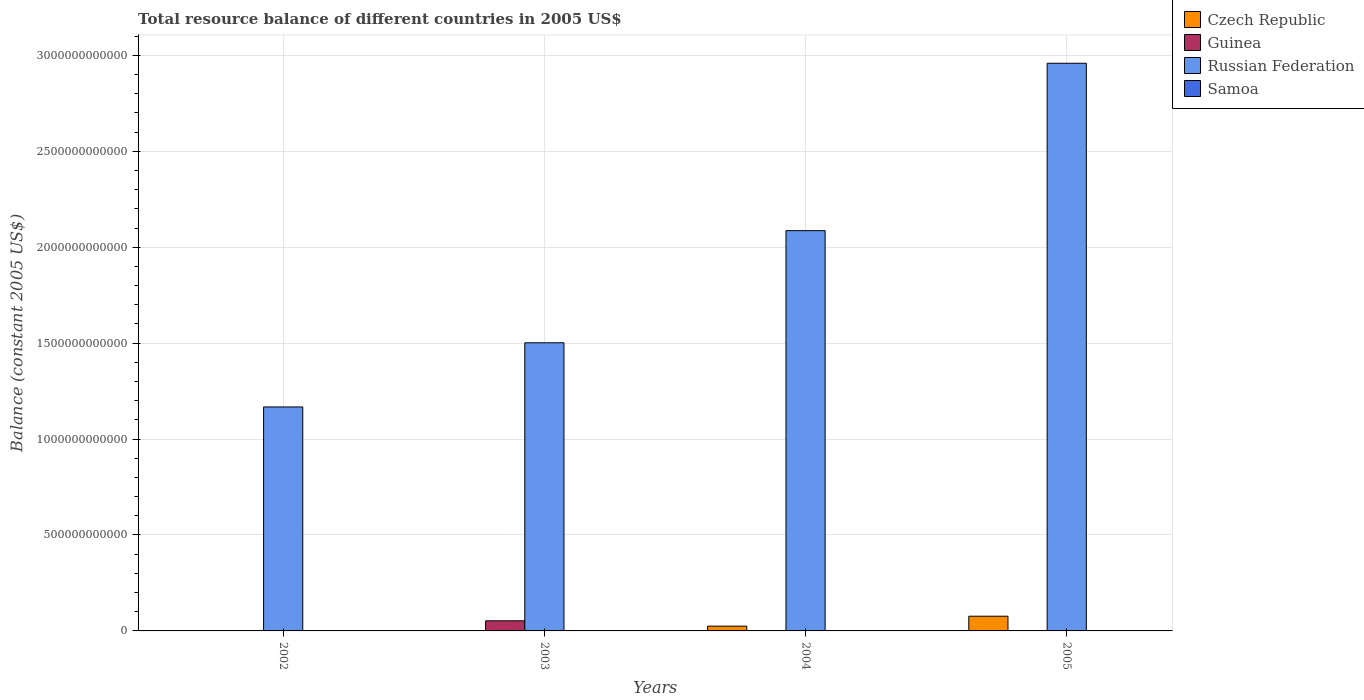How many different coloured bars are there?
Provide a short and direct response. 3. Are the number of bars per tick equal to the number of legend labels?
Offer a terse response. No. Are the number of bars on each tick of the X-axis equal?
Ensure brevity in your answer.  No. How many bars are there on the 3rd tick from the left?
Offer a terse response. 2. How many bars are there on the 4th tick from the right?
Give a very brief answer. 1. In how many cases, is the number of bars for a given year not equal to the number of legend labels?
Make the answer very short. 4. What is the total resource balance in Russian Federation in 2002?
Your answer should be very brief. 1.17e+12. Across all years, what is the maximum total resource balance in Czech Republic?
Provide a succinct answer. 7.67e+1. Across all years, what is the minimum total resource balance in Russian Federation?
Ensure brevity in your answer.  1.17e+12. What is the total total resource balance in Russian Federation in the graph?
Make the answer very short. 7.72e+12. What is the difference between the total resource balance in Russian Federation in 2002 and that in 2005?
Make the answer very short. -1.79e+12. What is the difference between the total resource balance in Czech Republic in 2005 and the total resource balance in Samoa in 2004?
Offer a terse response. 7.67e+1. What is the average total resource balance in Czech Republic per year?
Offer a terse response. 2.54e+1. In the year 2003, what is the difference between the total resource balance in Guinea and total resource balance in Russian Federation?
Keep it short and to the point. -1.45e+12. What is the ratio of the total resource balance in Russian Federation in 2002 to that in 2003?
Give a very brief answer. 0.78. What is the difference between the highest and the second highest total resource balance in Russian Federation?
Your answer should be very brief. 8.72e+11. What is the difference between the highest and the lowest total resource balance in Czech Republic?
Provide a succinct answer. 7.67e+1. Is the sum of the total resource balance in Russian Federation in 2002 and 2004 greater than the maximum total resource balance in Guinea across all years?
Your answer should be very brief. Yes. Is it the case that in every year, the sum of the total resource balance in Russian Federation and total resource balance in Czech Republic is greater than the total resource balance in Samoa?
Make the answer very short. Yes. How many bars are there?
Give a very brief answer. 7. How many years are there in the graph?
Offer a terse response. 4. What is the difference between two consecutive major ticks on the Y-axis?
Provide a short and direct response. 5.00e+11. Does the graph contain any zero values?
Ensure brevity in your answer.  Yes. Where does the legend appear in the graph?
Ensure brevity in your answer.  Top right. How many legend labels are there?
Provide a short and direct response. 4. How are the legend labels stacked?
Your response must be concise. Vertical. What is the title of the graph?
Your answer should be very brief. Total resource balance of different countries in 2005 US$. What is the label or title of the X-axis?
Offer a very short reply. Years. What is the label or title of the Y-axis?
Give a very brief answer. Balance (constant 2005 US$). What is the Balance (constant 2005 US$) in Czech Republic in 2002?
Offer a terse response. 0. What is the Balance (constant 2005 US$) of Russian Federation in 2002?
Provide a succinct answer. 1.17e+12. What is the Balance (constant 2005 US$) of Samoa in 2002?
Make the answer very short. 0. What is the Balance (constant 2005 US$) in Guinea in 2003?
Give a very brief answer. 5.28e+1. What is the Balance (constant 2005 US$) of Russian Federation in 2003?
Offer a very short reply. 1.50e+12. What is the Balance (constant 2005 US$) of Samoa in 2003?
Provide a succinct answer. 0. What is the Balance (constant 2005 US$) of Czech Republic in 2004?
Offer a terse response. 2.49e+1. What is the Balance (constant 2005 US$) in Russian Federation in 2004?
Make the answer very short. 2.09e+12. What is the Balance (constant 2005 US$) in Samoa in 2004?
Give a very brief answer. 0. What is the Balance (constant 2005 US$) of Czech Republic in 2005?
Your response must be concise. 7.67e+1. What is the Balance (constant 2005 US$) in Guinea in 2005?
Give a very brief answer. 0. What is the Balance (constant 2005 US$) in Russian Federation in 2005?
Offer a terse response. 2.96e+12. What is the Balance (constant 2005 US$) in Samoa in 2005?
Your answer should be compact. 0. Across all years, what is the maximum Balance (constant 2005 US$) of Czech Republic?
Your answer should be very brief. 7.67e+1. Across all years, what is the maximum Balance (constant 2005 US$) of Guinea?
Make the answer very short. 5.28e+1. Across all years, what is the maximum Balance (constant 2005 US$) of Russian Federation?
Offer a terse response. 2.96e+12. Across all years, what is the minimum Balance (constant 2005 US$) in Czech Republic?
Offer a terse response. 0. Across all years, what is the minimum Balance (constant 2005 US$) of Russian Federation?
Your response must be concise. 1.17e+12. What is the total Balance (constant 2005 US$) in Czech Republic in the graph?
Provide a succinct answer. 1.02e+11. What is the total Balance (constant 2005 US$) of Guinea in the graph?
Your answer should be very brief. 5.28e+1. What is the total Balance (constant 2005 US$) in Russian Federation in the graph?
Your answer should be compact. 7.72e+12. What is the total Balance (constant 2005 US$) of Samoa in the graph?
Give a very brief answer. 0. What is the difference between the Balance (constant 2005 US$) in Russian Federation in 2002 and that in 2003?
Provide a succinct answer. -3.34e+11. What is the difference between the Balance (constant 2005 US$) of Russian Federation in 2002 and that in 2004?
Make the answer very short. -9.19e+11. What is the difference between the Balance (constant 2005 US$) in Russian Federation in 2002 and that in 2005?
Provide a short and direct response. -1.79e+12. What is the difference between the Balance (constant 2005 US$) of Russian Federation in 2003 and that in 2004?
Keep it short and to the point. -5.84e+11. What is the difference between the Balance (constant 2005 US$) of Russian Federation in 2003 and that in 2005?
Provide a succinct answer. -1.46e+12. What is the difference between the Balance (constant 2005 US$) in Czech Republic in 2004 and that in 2005?
Provide a short and direct response. -5.18e+1. What is the difference between the Balance (constant 2005 US$) in Russian Federation in 2004 and that in 2005?
Keep it short and to the point. -8.72e+11. What is the difference between the Balance (constant 2005 US$) of Guinea in 2003 and the Balance (constant 2005 US$) of Russian Federation in 2004?
Provide a short and direct response. -2.03e+12. What is the difference between the Balance (constant 2005 US$) of Guinea in 2003 and the Balance (constant 2005 US$) of Russian Federation in 2005?
Your response must be concise. -2.91e+12. What is the difference between the Balance (constant 2005 US$) of Czech Republic in 2004 and the Balance (constant 2005 US$) of Russian Federation in 2005?
Make the answer very short. -2.93e+12. What is the average Balance (constant 2005 US$) of Czech Republic per year?
Your answer should be compact. 2.54e+1. What is the average Balance (constant 2005 US$) of Guinea per year?
Give a very brief answer. 1.32e+1. What is the average Balance (constant 2005 US$) in Russian Federation per year?
Make the answer very short. 1.93e+12. In the year 2003, what is the difference between the Balance (constant 2005 US$) in Guinea and Balance (constant 2005 US$) in Russian Federation?
Your response must be concise. -1.45e+12. In the year 2004, what is the difference between the Balance (constant 2005 US$) in Czech Republic and Balance (constant 2005 US$) in Russian Federation?
Keep it short and to the point. -2.06e+12. In the year 2005, what is the difference between the Balance (constant 2005 US$) in Czech Republic and Balance (constant 2005 US$) in Russian Federation?
Keep it short and to the point. -2.88e+12. What is the ratio of the Balance (constant 2005 US$) in Russian Federation in 2002 to that in 2003?
Give a very brief answer. 0.78. What is the ratio of the Balance (constant 2005 US$) in Russian Federation in 2002 to that in 2004?
Your answer should be very brief. 0.56. What is the ratio of the Balance (constant 2005 US$) of Russian Federation in 2002 to that in 2005?
Ensure brevity in your answer.  0.39. What is the ratio of the Balance (constant 2005 US$) of Russian Federation in 2003 to that in 2004?
Ensure brevity in your answer.  0.72. What is the ratio of the Balance (constant 2005 US$) of Russian Federation in 2003 to that in 2005?
Keep it short and to the point. 0.51. What is the ratio of the Balance (constant 2005 US$) in Czech Republic in 2004 to that in 2005?
Provide a short and direct response. 0.32. What is the ratio of the Balance (constant 2005 US$) of Russian Federation in 2004 to that in 2005?
Your response must be concise. 0.71. What is the difference between the highest and the second highest Balance (constant 2005 US$) in Russian Federation?
Provide a short and direct response. 8.72e+11. What is the difference between the highest and the lowest Balance (constant 2005 US$) in Czech Republic?
Your answer should be very brief. 7.67e+1. What is the difference between the highest and the lowest Balance (constant 2005 US$) in Guinea?
Your answer should be compact. 5.28e+1. What is the difference between the highest and the lowest Balance (constant 2005 US$) of Russian Federation?
Make the answer very short. 1.79e+12. 